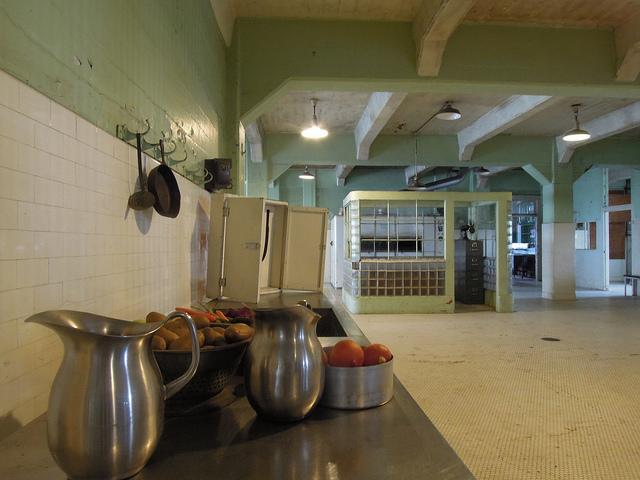Which food provides the most vitamin A?

Choices:
A) yam
B) potato
C) onion
D) carrot carrot 